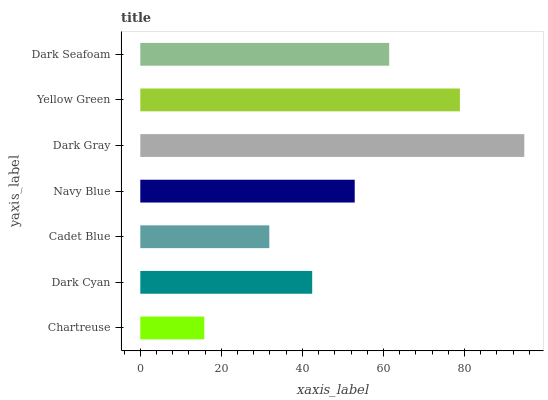Is Chartreuse the minimum?
Answer yes or no. Yes. Is Dark Gray the maximum?
Answer yes or no. Yes. Is Dark Cyan the minimum?
Answer yes or no. No. Is Dark Cyan the maximum?
Answer yes or no. No. Is Dark Cyan greater than Chartreuse?
Answer yes or no. Yes. Is Chartreuse less than Dark Cyan?
Answer yes or no. Yes. Is Chartreuse greater than Dark Cyan?
Answer yes or no. No. Is Dark Cyan less than Chartreuse?
Answer yes or no. No. Is Navy Blue the high median?
Answer yes or no. Yes. Is Navy Blue the low median?
Answer yes or no. Yes. Is Chartreuse the high median?
Answer yes or no. No. Is Yellow Green the low median?
Answer yes or no. No. 